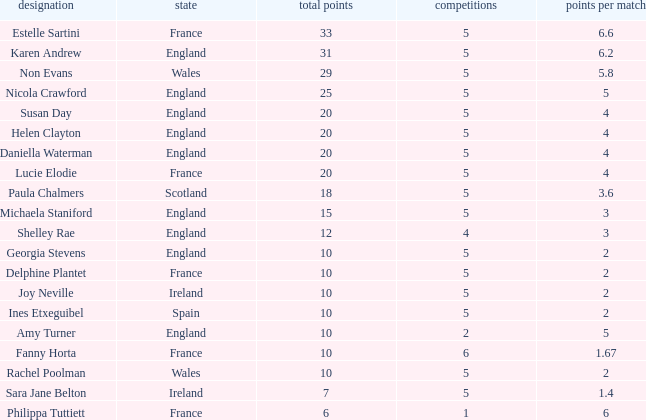Would you mind parsing the complete table? {'header': ['designation', 'state', 'total points', 'competitions', 'points per match'], 'rows': [['Estelle Sartini', 'France', '33', '5', '6.6'], ['Karen Andrew', 'England', '31', '5', '6.2'], ['Non Evans', 'Wales', '29', '5', '5.8'], ['Nicola Crawford', 'England', '25', '5', '5'], ['Susan Day', 'England', '20', '5', '4'], ['Helen Clayton', 'England', '20', '5', '4'], ['Daniella Waterman', 'England', '20', '5', '4'], ['Lucie Elodie', 'France', '20', '5', '4'], ['Paula Chalmers', 'Scotland', '18', '5', '3.6'], ['Michaela Staniford', 'England', '15', '5', '3'], ['Shelley Rae', 'England', '12', '4', '3'], ['Georgia Stevens', 'England', '10', '5', '2'], ['Delphine Plantet', 'France', '10', '5', '2'], ['Joy Neville', 'Ireland', '10', '5', '2'], ['Ines Etxeguibel', 'Spain', '10', '5', '2'], ['Amy Turner', 'England', '10', '2', '5'], ['Fanny Horta', 'France', '10', '6', '1.67'], ['Rachel Poolman', 'Wales', '10', '5', '2'], ['Sara Jane Belton', 'Ireland', '7', '5', '1.4'], ['Philippa Tuttiett', 'France', '6', '1', '6']]} Can you tell me the average Points that has a Pts/game larger than 4, and the Nation of england, and the Games smaller than 5? 10.0. 